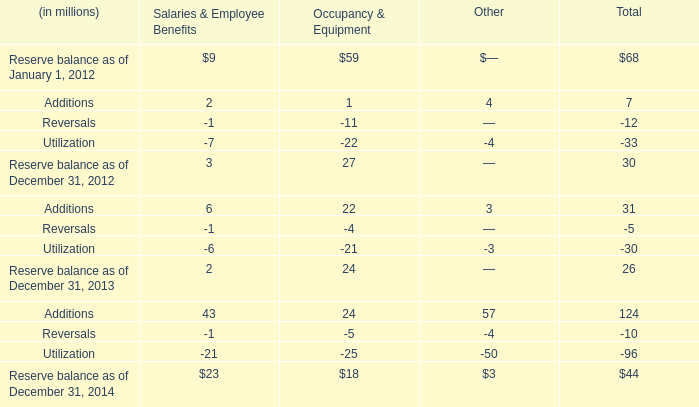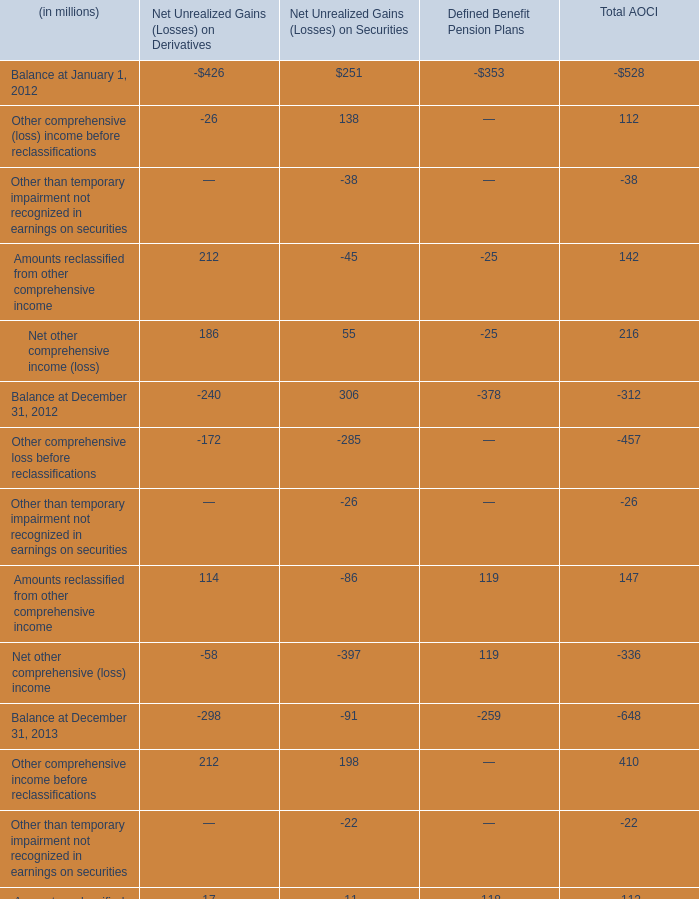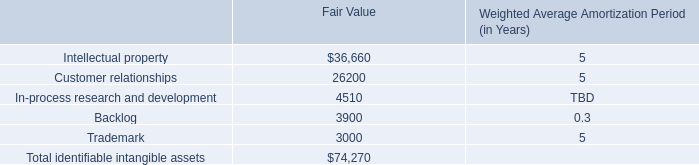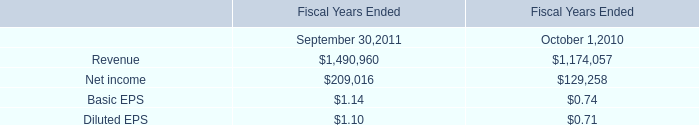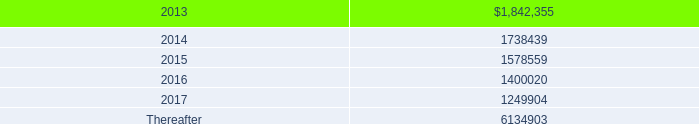Which year / section is Balance at December 31 in Net Unrealized Gains (Losses) on Derivatives the lowest? 
Answer: 2013. 